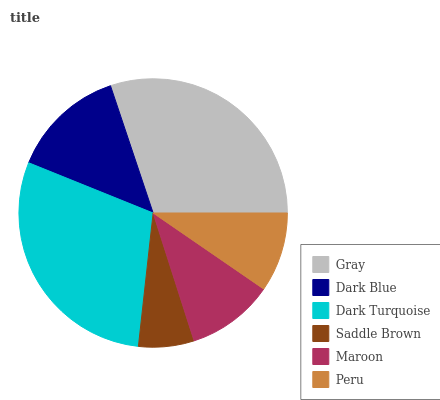Is Saddle Brown the minimum?
Answer yes or no. Yes. Is Gray the maximum?
Answer yes or no. Yes. Is Dark Blue the minimum?
Answer yes or no. No. Is Dark Blue the maximum?
Answer yes or no. No. Is Gray greater than Dark Blue?
Answer yes or no. Yes. Is Dark Blue less than Gray?
Answer yes or no. Yes. Is Dark Blue greater than Gray?
Answer yes or no. No. Is Gray less than Dark Blue?
Answer yes or no. No. Is Dark Blue the high median?
Answer yes or no. Yes. Is Maroon the low median?
Answer yes or no. Yes. Is Maroon the high median?
Answer yes or no. No. Is Peru the low median?
Answer yes or no. No. 